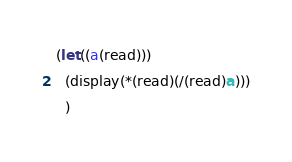<code> <loc_0><loc_0><loc_500><loc_500><_Scheme_>(let((a(read)))
  (display(*(read)(/(read)a)))
  )
</code> 